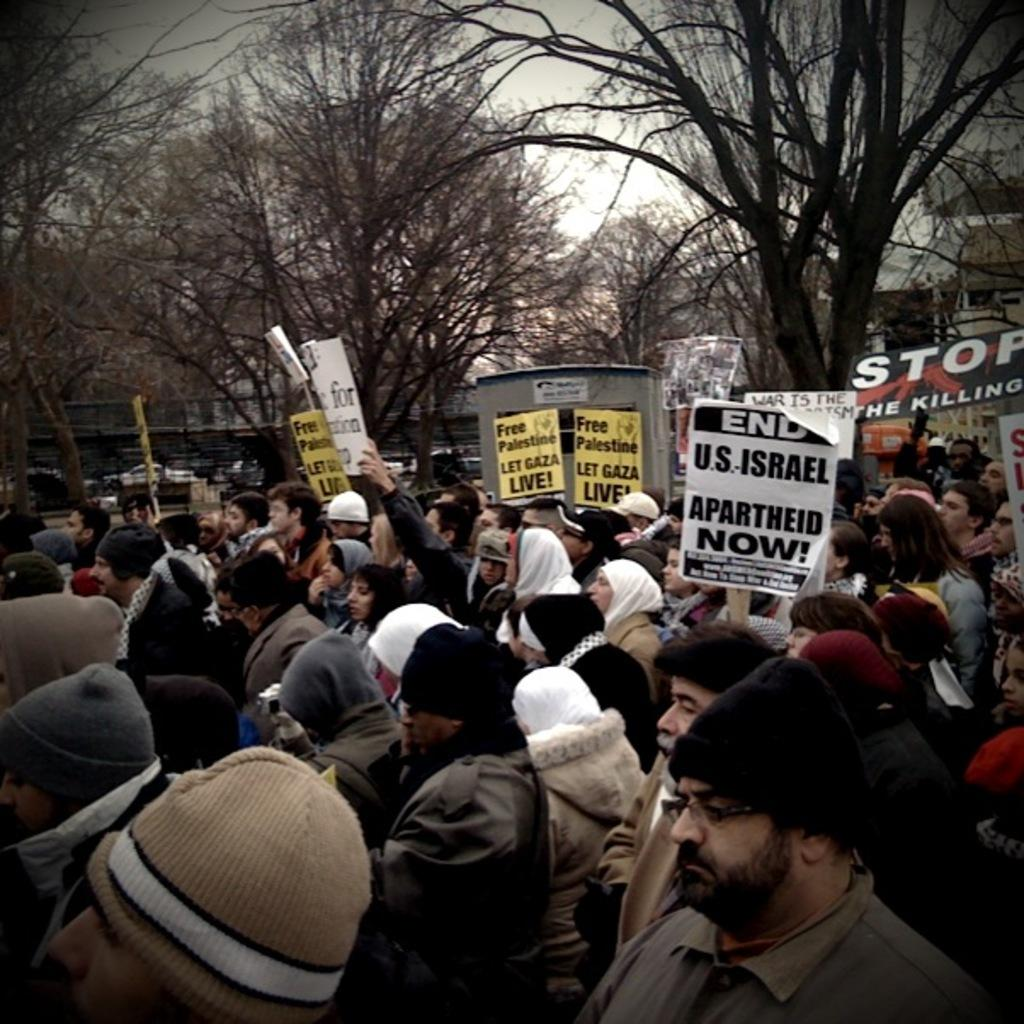How many people are in the image? There is a group of people in the image. What are the people doing in the image? The people are standing and holding a board. What is written on the board? There is writing on the board. What can be seen in the background of the image? There are trees, a building, and the sky visible in the background of the image. What type of pot is being used as a weapon by one of the people in the image? There is no pot or any weapon present in the image. How many plates are being held by the people in the image? There are no plates visible in the image; the people are holding a board with writing on it. 